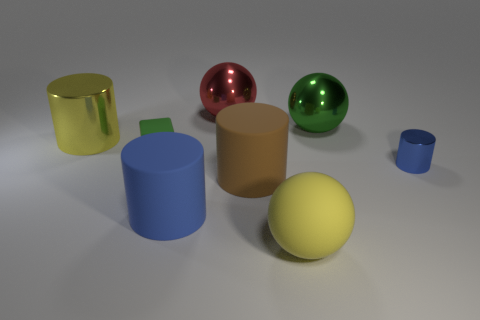Can you describe the colors of the objects present? Certainly, there are six objects with distinct colors. From left to right, there's a metallic gold cylinder, a glossy red sphere, a matte tan cylinder, a matte sky blue cylinder, a glossy green sphere, and a matte yellow sphere.  Are there any other spheres besides the red and green one? Yes, aside from the glossy red and green spheres, there is also a matte yellow sphere to the right in the image. 